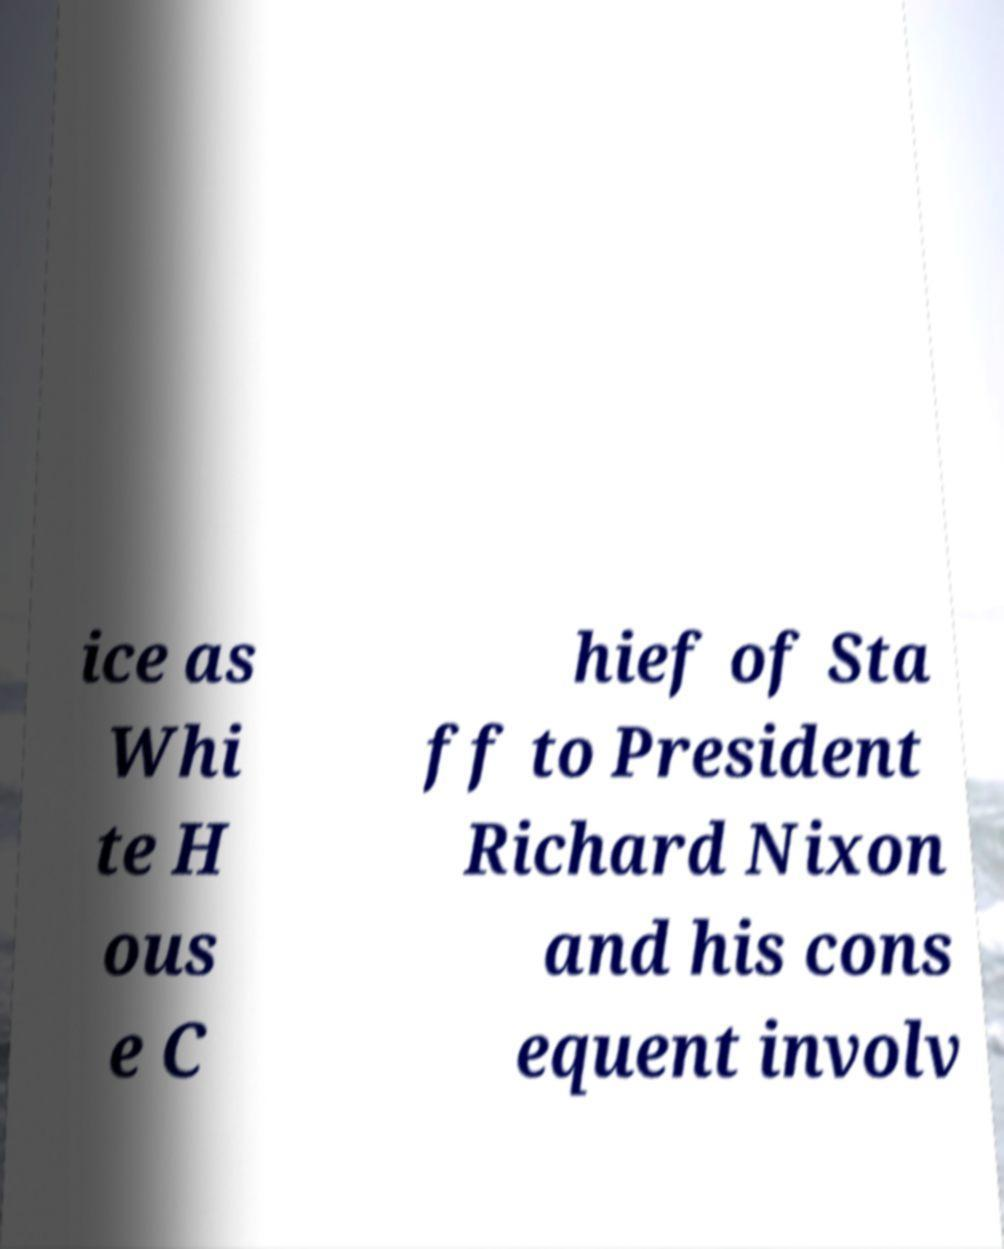For documentation purposes, I need the text within this image transcribed. Could you provide that? ice as Whi te H ous e C hief of Sta ff to President Richard Nixon and his cons equent involv 